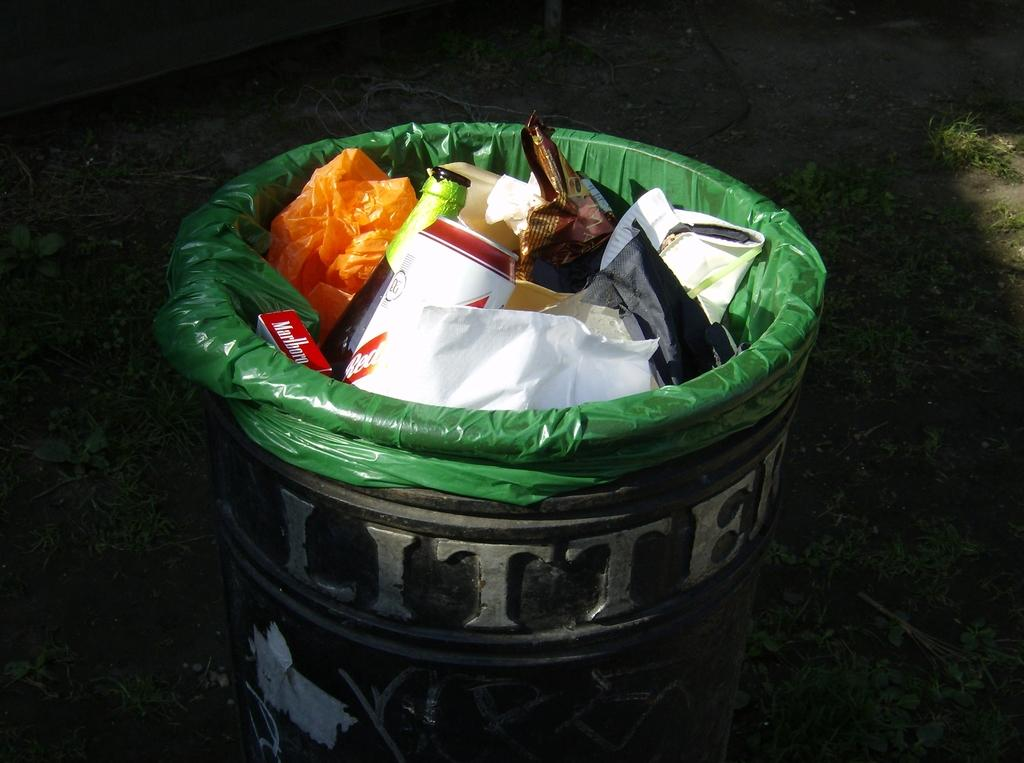<image>
Relay a brief, clear account of the picture shown. A bin labelled Litter and lined with a green bin bag is full of various types of rubbish. 